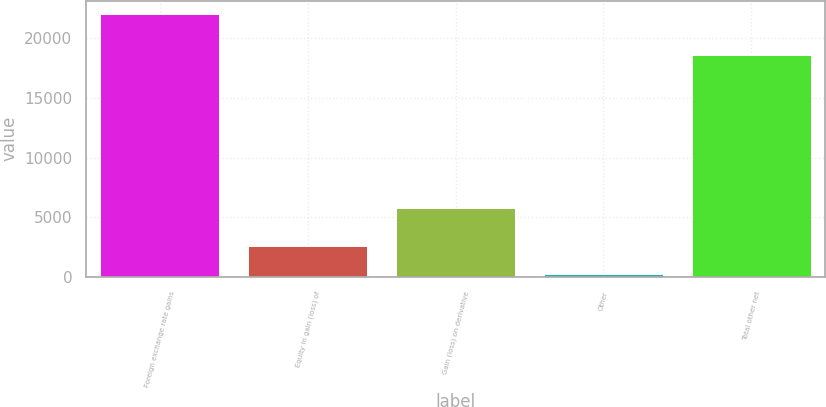Convert chart to OTSL. <chart><loc_0><loc_0><loc_500><loc_500><bar_chart><fcel>Foreign exchange rate gains<fcel>Equity in gain (loss) of<fcel>Gain (loss) on derivative<fcel>Other<fcel>Total other net<nl><fcel>22047<fcel>2614<fcel>5748<fcel>256<fcel>18607<nl></chart> 